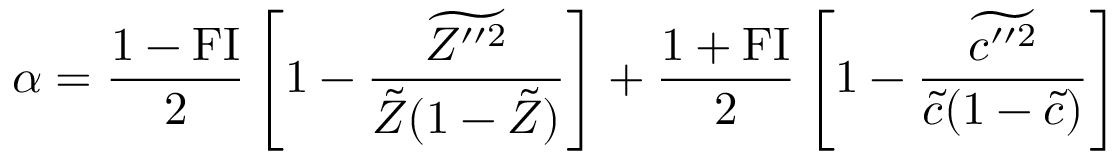Convert formula to latex. <formula><loc_0><loc_0><loc_500><loc_500>\alpha = \frac { 1 - F I } { 2 } \left [ 1 - \frac { \widetilde { Z ^ { \prime \prime 2 } } } { \tilde { Z } ( 1 - \tilde { Z } ) } \right ] + \frac { 1 + F I } { 2 } \left [ 1 - \frac { \widetilde { c ^ { \prime \prime 2 } } } { \tilde { c } ( 1 - \tilde { c } ) } \right ]</formula> 